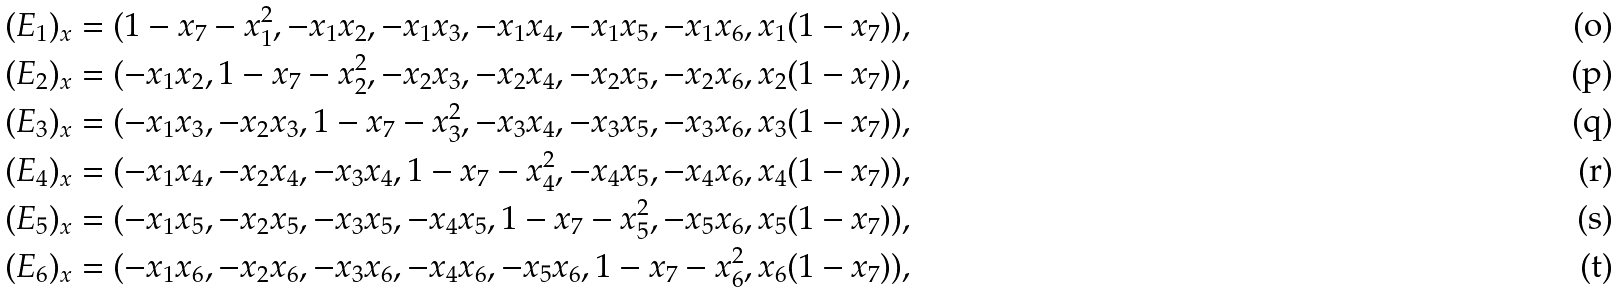<formula> <loc_0><loc_0><loc_500><loc_500>( E _ { 1 } ) _ { x } = ( 1 - x _ { 7 } - x _ { 1 } ^ { 2 } , - x _ { 1 } x _ { 2 } , - x _ { 1 } x _ { 3 } , - x _ { 1 } x _ { 4 } , - x _ { 1 } x _ { 5 } , - x _ { 1 } x _ { 6 } , x _ { 1 } ( 1 - x _ { 7 } ) ) , \\ ( E _ { 2 } ) _ { x } = ( - x _ { 1 } x _ { 2 } , 1 - x _ { 7 } - x _ { 2 } ^ { 2 } , - x _ { 2 } x _ { 3 } , - x _ { 2 } x _ { 4 } , - x _ { 2 } x _ { 5 } , - x _ { 2 } x _ { 6 } , x _ { 2 } ( 1 - x _ { 7 } ) ) , \\ ( E _ { 3 } ) _ { x } = ( - x _ { 1 } x _ { 3 } , - x _ { 2 } x _ { 3 } , 1 - x _ { 7 } - x _ { 3 } ^ { 2 } , - x _ { 3 } x _ { 4 } , - x _ { 3 } x _ { 5 } , - x _ { 3 } x _ { 6 } , x _ { 3 } ( 1 - x _ { 7 } ) ) , \\ ( E _ { 4 } ) _ { x } = ( - x _ { 1 } x _ { 4 } , - x _ { 2 } x _ { 4 } , - x _ { 3 } x _ { 4 } , 1 - x _ { 7 } - x _ { 4 } ^ { 2 } , - x _ { 4 } x _ { 5 } , - x _ { 4 } x _ { 6 } , x _ { 4 } ( 1 - x _ { 7 } ) ) , \\ ( E _ { 5 } ) _ { x } = ( - x _ { 1 } x _ { 5 } , - x _ { 2 } x _ { 5 } , - x _ { 3 } x _ { 5 } , - x _ { 4 } x _ { 5 } , 1 - x _ { 7 } - x _ { 5 } ^ { 2 } , - x _ { 5 } x _ { 6 } , x _ { 5 } ( 1 - x _ { 7 } ) ) , \\ ( E _ { 6 } ) _ { x } = ( - x _ { 1 } x _ { 6 } , - x _ { 2 } x _ { 6 } , - x _ { 3 } x _ { 6 } , - x _ { 4 } x _ { 6 } , - x _ { 5 } x _ { 6 } , 1 - x _ { 7 } - x _ { 6 } ^ { 2 } , x _ { 6 } ( 1 - x _ { 7 } ) ) ,</formula> 